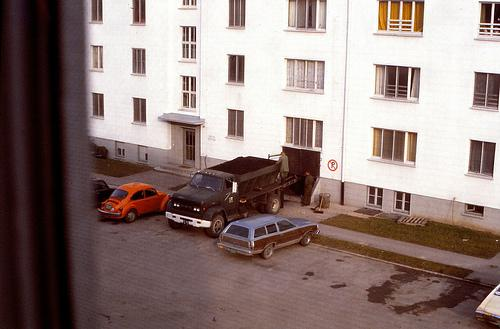What unique feature can be observed on the blue car? The blue car has brown side panels. What color is the leftmost car in the image? The leftmost car is red. How many people are in this image and what are they doing? There are 4 people: 1 man standing in front of the entrance, 1 man standing near a broom, 1 man on top of the black truck, and 1 man standing on the side of the truck. What can be seen on the ground in front of the building? A paved parking lot, a grassy area, and a large dirt mark on the street. Count the number of vehicles in the scene. There are 5 vehicles: 3 cars, 1 truck and an old wagon. What type of sign can be seen on the building's exterior wall? A no parking sign is visible on the building's exterior wall. Identify any items related to cleaning in the scene and describe their positions. There's a wooden outdoor broom leaning on a trashcan beside the delivery entrance of the building. Describe the building's exterior features in the image. The building is white with a red and white sign, has orange curtains in the windows, and a no parking sign on its exterior wall. Are there any authorities in the image enforcing the no parking rule? No, there are no authorities present enforcing the no parking rule. What is the color of the curtains in the window? The curtains in the window are orange. Is there a yellow sign on the building's wall? The sign mentioned in the image is red and white, not yellow, leading to a misleading instruction. Is the man standing near a mop instead of a broom? The image contains a man standing near a broom, not a mop, making this instruction misleading. Is there a blue truck parked in front of the entrance? The truck mentioned in the image is black, not blue, therefore the instruction is misleading. Is the building in the image pink? The building mentioned in the image is white, not pink, that makes it a misleading instruction. Are the curtains in the window green? The curtains mentioned in the image are orange, not green, which makes the instruction misleading. Can you see a purple car next to the huge black truck? There are a blue-and-brown car and an orange car next to the black truck, but there's no purple car mentioned, making the question misleading. 